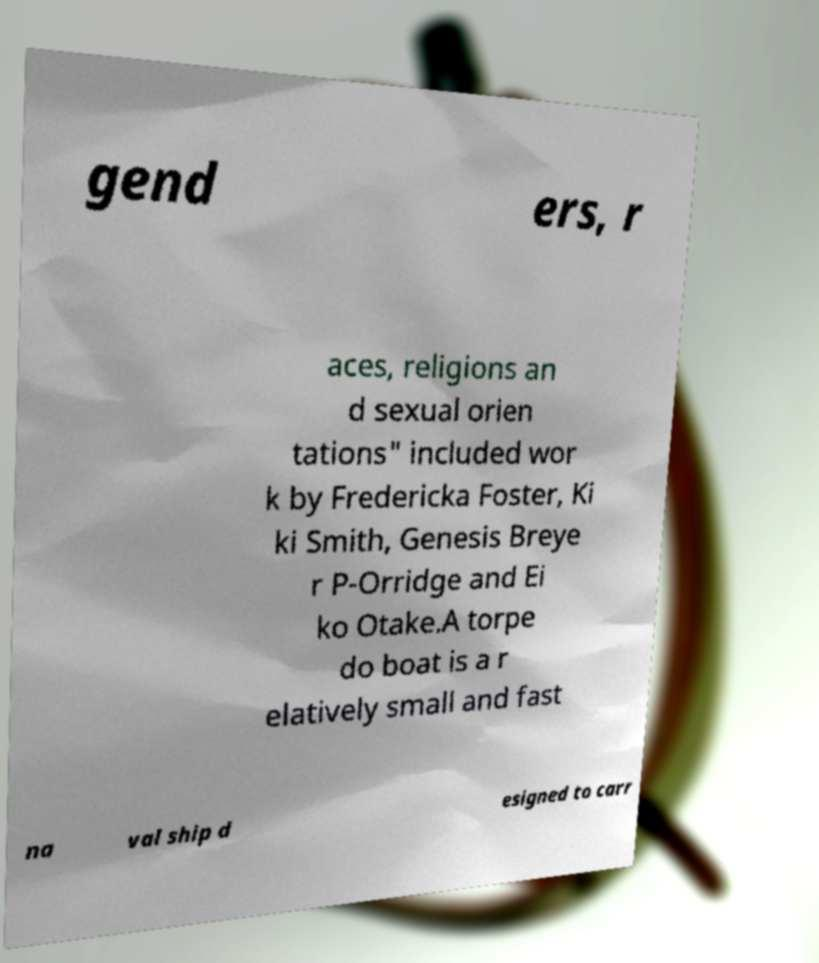There's text embedded in this image that I need extracted. Can you transcribe it verbatim? gend ers, r aces, religions an d sexual orien tations" included wor k by Fredericka Foster, Ki ki Smith, Genesis Breye r P-Orridge and Ei ko Otake.A torpe do boat is a r elatively small and fast na val ship d esigned to carr 